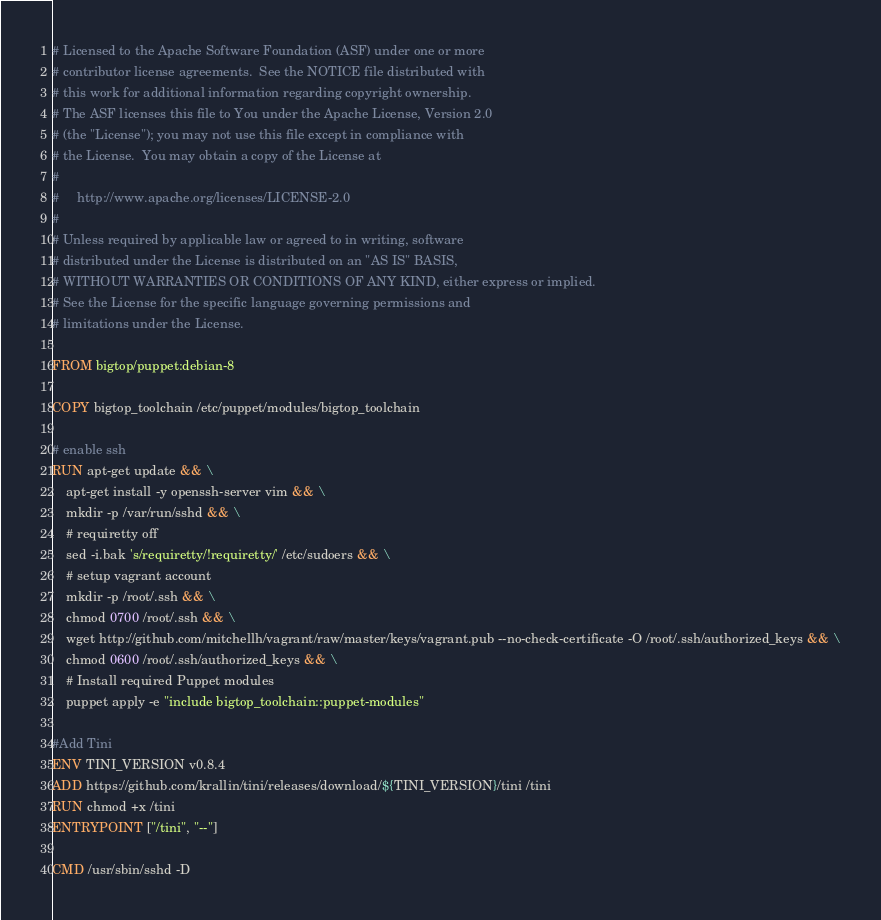Convert code to text. <code><loc_0><loc_0><loc_500><loc_500><_Dockerfile_># Licensed to the Apache Software Foundation (ASF) under one or more
# contributor license agreements.  See the NOTICE file distributed with
# this work for additional information regarding copyright ownership.
# The ASF licenses this file to You under the Apache License, Version 2.0
# (the "License"); you may not use this file except in compliance with
# the License.  You may obtain a copy of the License at
#
#     http://www.apache.org/licenses/LICENSE-2.0
#
# Unless required by applicable law or agreed to in writing, software
# distributed under the License is distributed on an "AS IS" BASIS,
# WITHOUT WARRANTIES OR CONDITIONS OF ANY KIND, either express or implied.
# See the License for the specific language governing permissions and
# limitations under the License.

FROM bigtop/puppet:debian-8

COPY bigtop_toolchain /etc/puppet/modules/bigtop_toolchain

# enable ssh
RUN apt-get update && \
    apt-get install -y openssh-server vim && \
    mkdir -p /var/run/sshd && \
    # requiretty off
    sed -i.bak 's/requiretty/!requiretty/' /etc/sudoers && \
    # setup vagrant account
    mkdir -p /root/.ssh && \
    chmod 0700 /root/.ssh && \
    wget http://github.com/mitchellh/vagrant/raw/master/keys/vagrant.pub --no-check-certificate -O /root/.ssh/authorized_keys && \
    chmod 0600 /root/.ssh/authorized_keys && \
    # Install required Puppet modules
    puppet apply -e "include bigtop_toolchain::puppet-modules"

#Add Tini
ENV TINI_VERSION v0.8.4
ADD https://github.com/krallin/tini/releases/download/${TINI_VERSION}/tini /tini
RUN chmod +x /tini
ENTRYPOINT ["/tini", "--"]

CMD /usr/sbin/sshd -D
</code> 